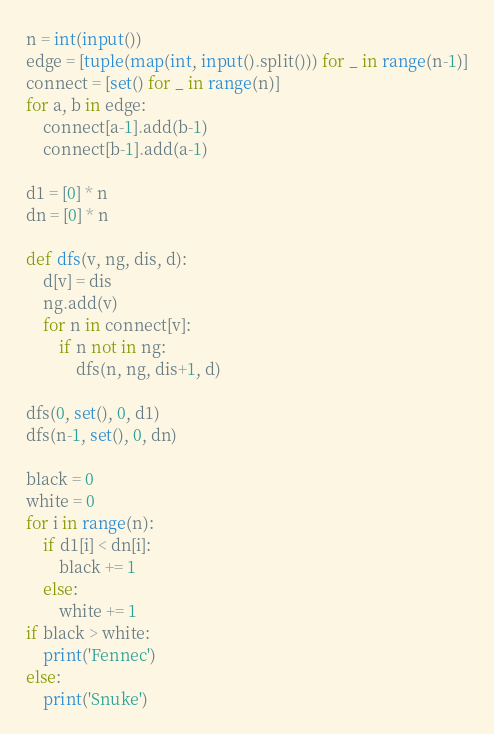<code> <loc_0><loc_0><loc_500><loc_500><_Python_>n = int(input())
edge = [tuple(map(int, input().split())) for _ in range(n-1)]
connect = [set() for _ in range(n)]
for a, b in edge:
    connect[a-1].add(b-1)
    connect[b-1].add(a-1)

d1 = [0] * n
dn = [0] * n

def dfs(v, ng, dis, d):
    d[v] = dis
    ng.add(v)
    for n in connect[v]:
        if n not in ng:
            dfs(n, ng, dis+1, d)

dfs(0, set(), 0, d1)
dfs(n-1, set(), 0, dn)

black = 0
white = 0
for i in range(n):
    if d1[i] < dn[i]:
        black += 1
    else:
        white += 1
if black > white:
    print('Fennec')
else:
    print('Snuke')</code> 